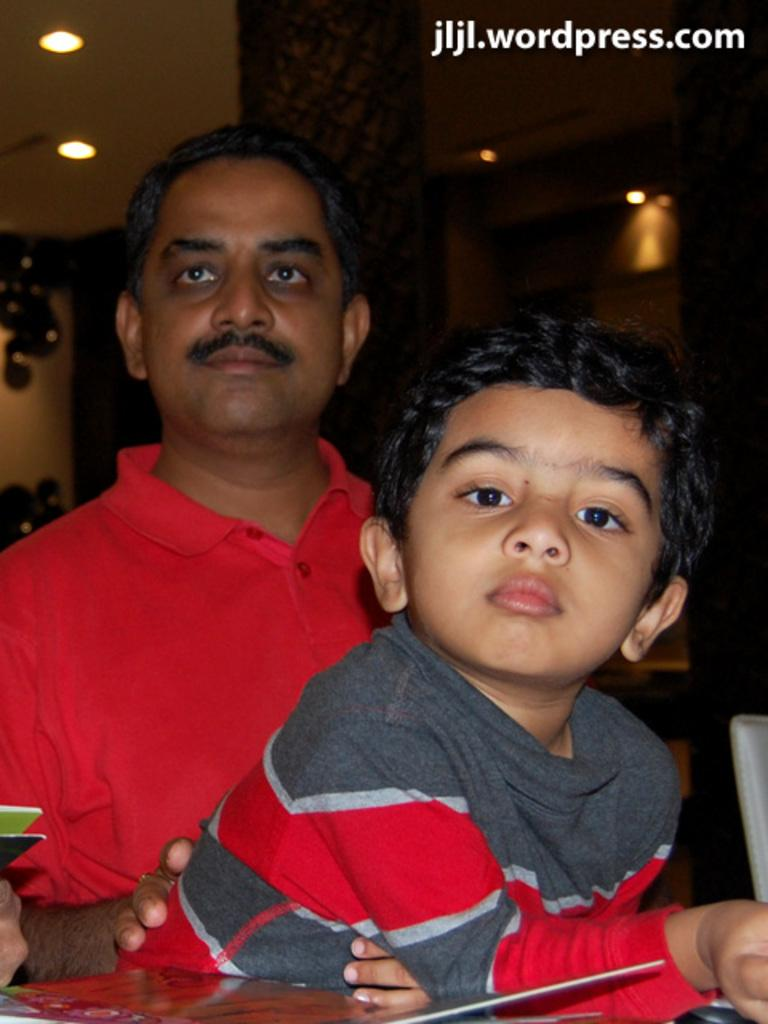How many people are in the image? There are two people in the image. What can be seen around the people? There are objects around the people. What is on the roof in the image? There are lights visible on the roof. What architectural features are present in the image? There are pillars in the image. What type of gold object is being crushed by the people in the image? There is no gold object being crushed in the image; the provided facts do not mention any gold objects or any action of crushing. 